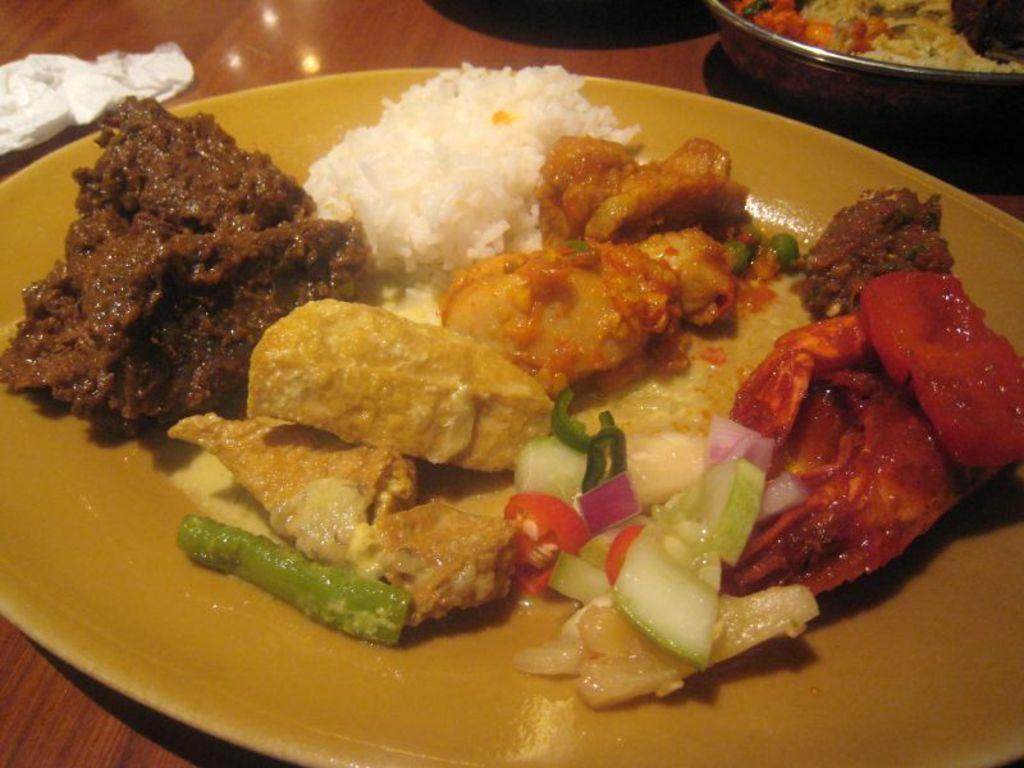In one or two sentences, can you explain what this image depicts? In this image I can see a plate kept on the table , and I can see food item visible on the plate and at the top I can see a bowl contain a food item. 